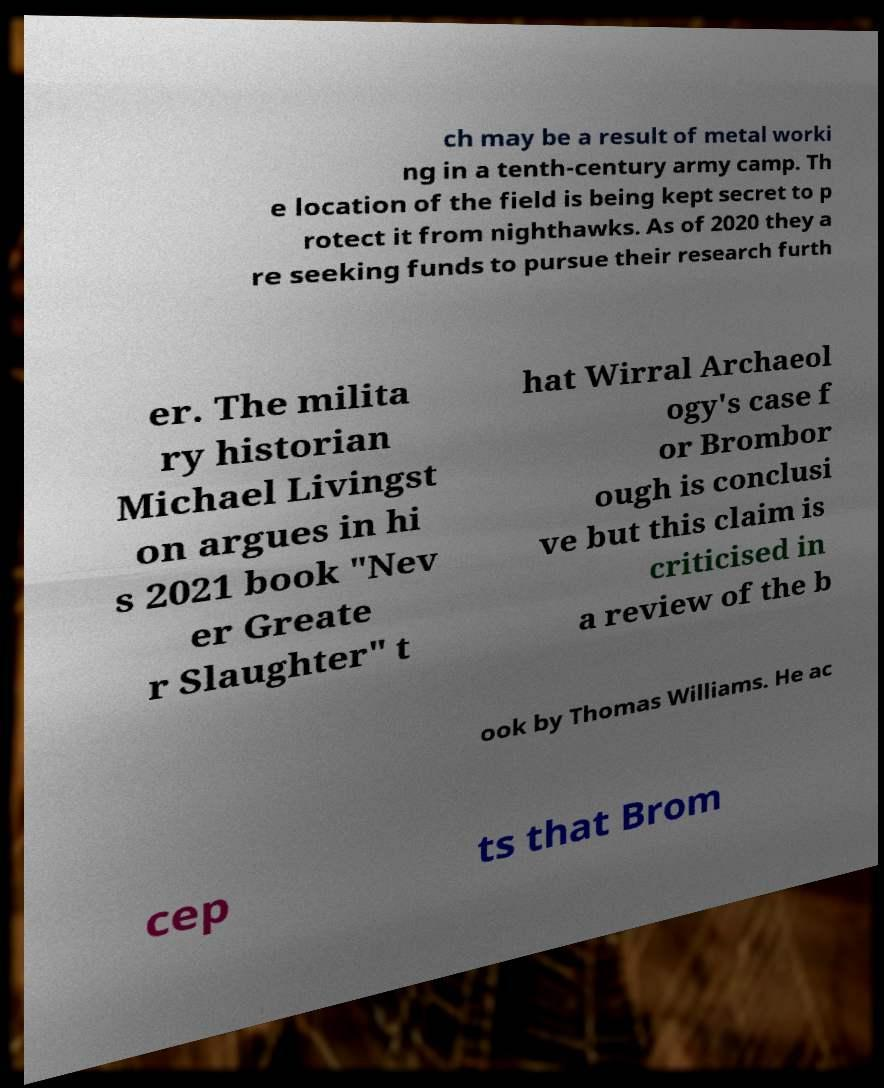Could you extract and type out the text from this image? ch may be a result of metal worki ng in a tenth-century army camp. Th e location of the field is being kept secret to p rotect it from nighthawks. As of 2020 they a re seeking funds to pursue their research furth er. The milita ry historian Michael Livingst on argues in hi s 2021 book "Nev er Greate r Slaughter" t hat Wirral Archaeol ogy's case f or Brombor ough is conclusi ve but this claim is criticised in a review of the b ook by Thomas Williams. He ac cep ts that Brom 